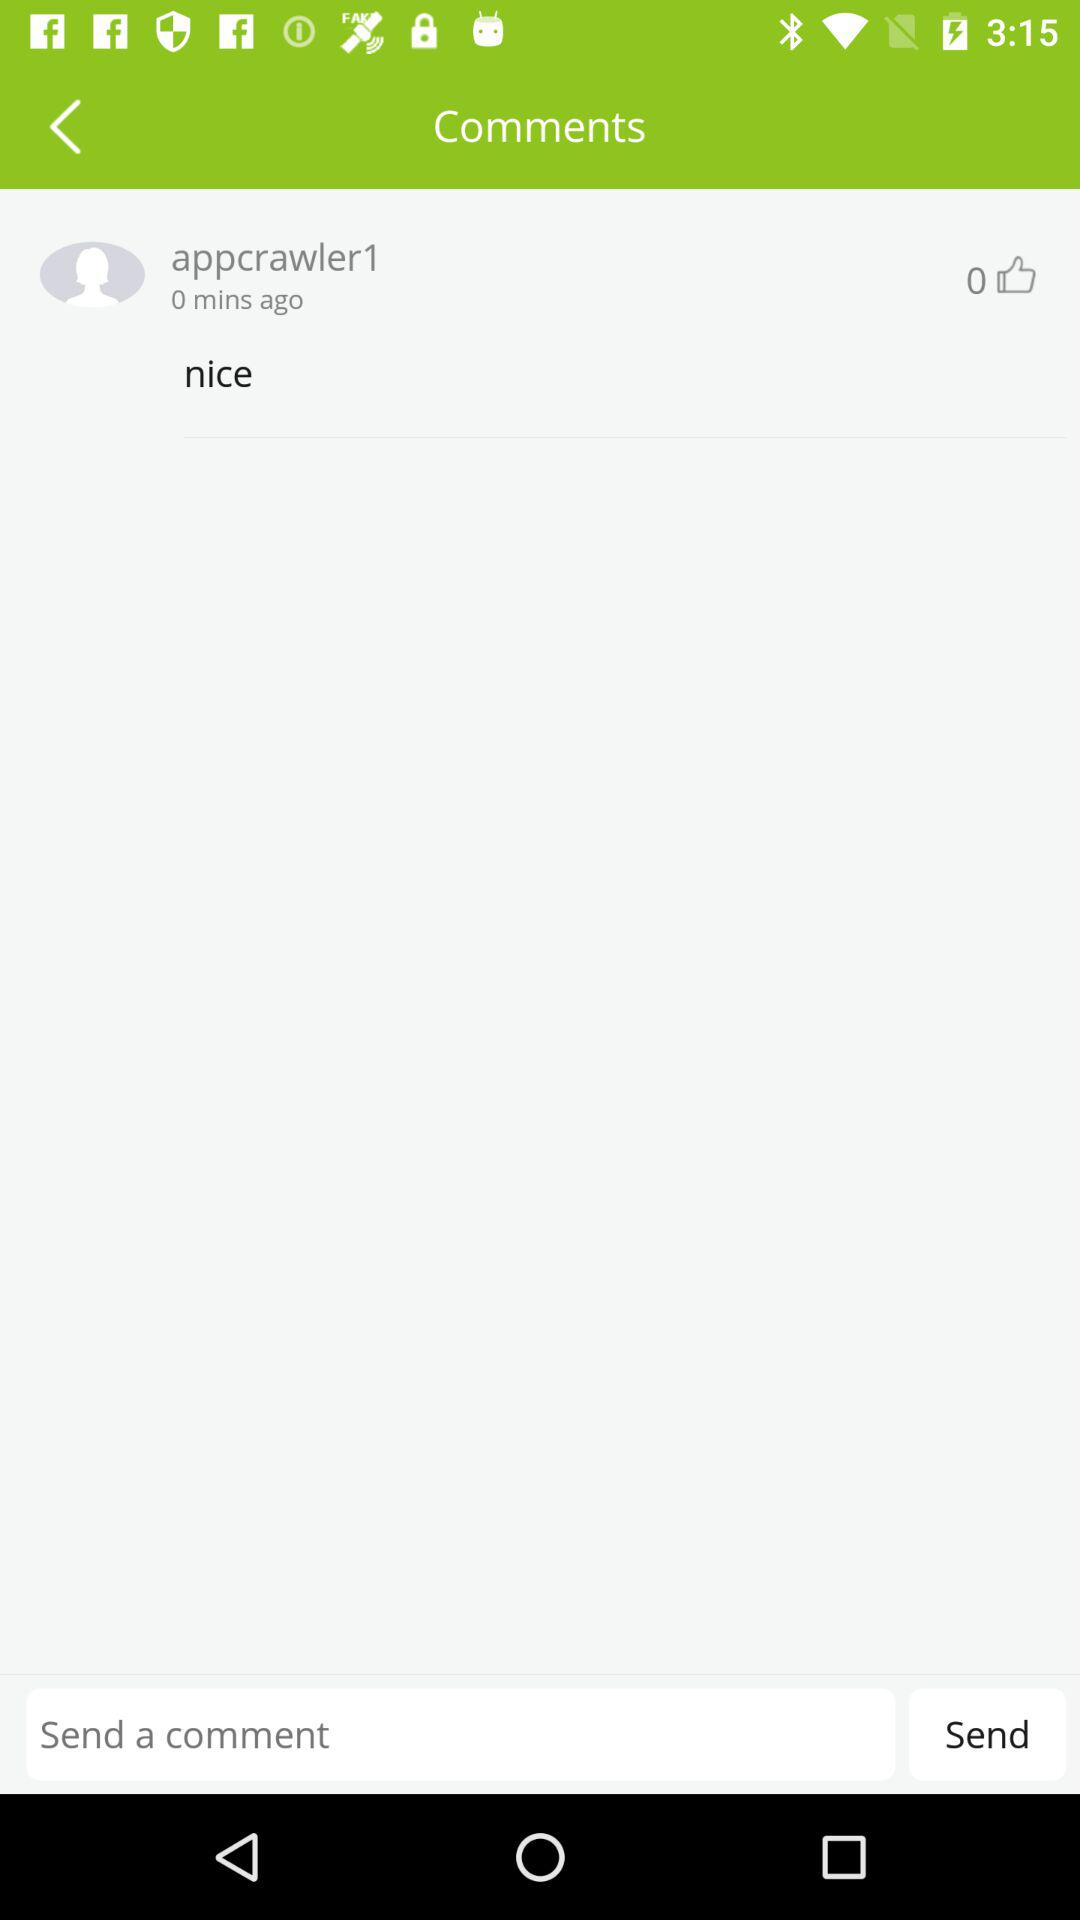How many minutes ago was the comment posted? The comment was posted 0 minutes ago. 